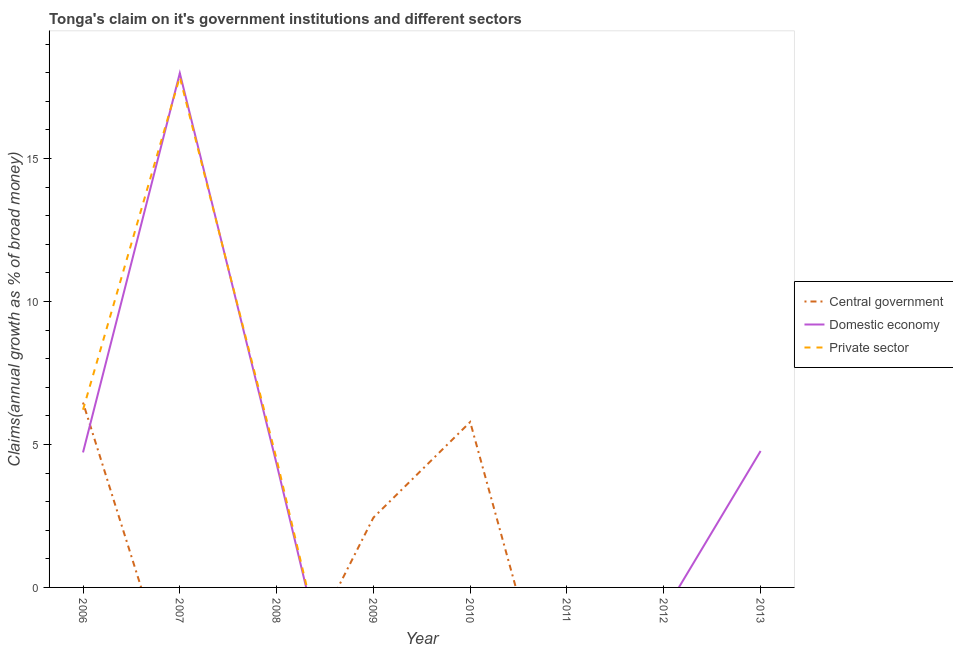How many different coloured lines are there?
Provide a succinct answer. 3. What is the percentage of claim on the central government in 2011?
Your answer should be compact. 0. Across all years, what is the maximum percentage of claim on the central government?
Keep it short and to the point. 6.47. Across all years, what is the minimum percentage of claim on the central government?
Your response must be concise. 0. What is the total percentage of claim on the central government in the graph?
Make the answer very short. 14.69. What is the difference between the percentage of claim on the domestic economy in 2012 and the percentage of claim on the central government in 2009?
Give a very brief answer. -2.44. What is the average percentage of claim on the private sector per year?
Your answer should be compact. 3.57. In the year 2006, what is the difference between the percentage of claim on the domestic economy and percentage of claim on the private sector?
Give a very brief answer. -1.49. What is the difference between the highest and the second highest percentage of claim on the domestic economy?
Your response must be concise. 13.21. What is the difference between the highest and the lowest percentage of claim on the domestic economy?
Your answer should be compact. 17.99. Is it the case that in every year, the sum of the percentage of claim on the central government and percentage of claim on the domestic economy is greater than the percentage of claim on the private sector?
Provide a succinct answer. No. What is the difference between two consecutive major ticks on the Y-axis?
Keep it short and to the point. 5. Does the graph contain any zero values?
Your response must be concise. Yes. How many legend labels are there?
Offer a very short reply. 3. What is the title of the graph?
Offer a very short reply. Tonga's claim on it's government institutions and different sectors. Does "Taxes" appear as one of the legend labels in the graph?
Your answer should be very brief. No. What is the label or title of the X-axis?
Your response must be concise. Year. What is the label or title of the Y-axis?
Keep it short and to the point. Claims(annual growth as % of broad money). What is the Claims(annual growth as % of broad money) of Central government in 2006?
Provide a succinct answer. 6.47. What is the Claims(annual growth as % of broad money) in Domestic economy in 2006?
Offer a terse response. 4.72. What is the Claims(annual growth as % of broad money) in Private sector in 2006?
Give a very brief answer. 6.22. What is the Claims(annual growth as % of broad money) of Domestic economy in 2007?
Your response must be concise. 17.99. What is the Claims(annual growth as % of broad money) of Private sector in 2007?
Provide a short and direct response. 17.85. What is the Claims(annual growth as % of broad money) in Central government in 2008?
Give a very brief answer. 0. What is the Claims(annual growth as % of broad money) of Domestic economy in 2008?
Provide a succinct answer. 4.32. What is the Claims(annual growth as % of broad money) in Private sector in 2008?
Provide a succinct answer. 4.48. What is the Claims(annual growth as % of broad money) in Central government in 2009?
Make the answer very short. 2.44. What is the Claims(annual growth as % of broad money) in Domestic economy in 2009?
Make the answer very short. 0. What is the Claims(annual growth as % of broad money) of Private sector in 2009?
Give a very brief answer. 0. What is the Claims(annual growth as % of broad money) of Central government in 2010?
Keep it short and to the point. 5.79. What is the Claims(annual growth as % of broad money) in Domestic economy in 2010?
Your answer should be compact. 0. What is the Claims(annual growth as % of broad money) in Private sector in 2011?
Your answer should be compact. 0. What is the Claims(annual growth as % of broad money) of Domestic economy in 2012?
Provide a short and direct response. 0. What is the Claims(annual growth as % of broad money) in Central government in 2013?
Your response must be concise. 0. What is the Claims(annual growth as % of broad money) of Domestic economy in 2013?
Your answer should be very brief. 4.77. Across all years, what is the maximum Claims(annual growth as % of broad money) in Central government?
Give a very brief answer. 6.47. Across all years, what is the maximum Claims(annual growth as % of broad money) in Domestic economy?
Offer a very short reply. 17.99. Across all years, what is the maximum Claims(annual growth as % of broad money) of Private sector?
Offer a terse response. 17.85. Across all years, what is the minimum Claims(annual growth as % of broad money) of Central government?
Offer a terse response. 0. What is the total Claims(annual growth as % of broad money) of Central government in the graph?
Provide a succinct answer. 14.69. What is the total Claims(annual growth as % of broad money) in Domestic economy in the graph?
Keep it short and to the point. 31.8. What is the total Claims(annual growth as % of broad money) of Private sector in the graph?
Give a very brief answer. 28.55. What is the difference between the Claims(annual growth as % of broad money) in Domestic economy in 2006 and that in 2007?
Give a very brief answer. -13.26. What is the difference between the Claims(annual growth as % of broad money) of Private sector in 2006 and that in 2007?
Offer a very short reply. -11.63. What is the difference between the Claims(annual growth as % of broad money) in Domestic economy in 2006 and that in 2008?
Offer a terse response. 0.4. What is the difference between the Claims(annual growth as % of broad money) of Private sector in 2006 and that in 2008?
Give a very brief answer. 1.73. What is the difference between the Claims(annual growth as % of broad money) of Central government in 2006 and that in 2009?
Your answer should be very brief. 4.02. What is the difference between the Claims(annual growth as % of broad money) in Central government in 2006 and that in 2010?
Your response must be concise. 0.68. What is the difference between the Claims(annual growth as % of broad money) of Domestic economy in 2006 and that in 2013?
Ensure brevity in your answer.  -0.05. What is the difference between the Claims(annual growth as % of broad money) in Domestic economy in 2007 and that in 2008?
Make the answer very short. 13.67. What is the difference between the Claims(annual growth as % of broad money) in Private sector in 2007 and that in 2008?
Provide a succinct answer. 13.37. What is the difference between the Claims(annual growth as % of broad money) of Domestic economy in 2007 and that in 2013?
Offer a very short reply. 13.21. What is the difference between the Claims(annual growth as % of broad money) in Domestic economy in 2008 and that in 2013?
Make the answer very short. -0.45. What is the difference between the Claims(annual growth as % of broad money) in Central government in 2009 and that in 2010?
Give a very brief answer. -3.34. What is the difference between the Claims(annual growth as % of broad money) of Central government in 2006 and the Claims(annual growth as % of broad money) of Domestic economy in 2007?
Offer a terse response. -11.52. What is the difference between the Claims(annual growth as % of broad money) in Central government in 2006 and the Claims(annual growth as % of broad money) in Private sector in 2007?
Ensure brevity in your answer.  -11.38. What is the difference between the Claims(annual growth as % of broad money) of Domestic economy in 2006 and the Claims(annual growth as % of broad money) of Private sector in 2007?
Give a very brief answer. -13.13. What is the difference between the Claims(annual growth as % of broad money) of Central government in 2006 and the Claims(annual growth as % of broad money) of Domestic economy in 2008?
Your answer should be compact. 2.15. What is the difference between the Claims(annual growth as % of broad money) of Central government in 2006 and the Claims(annual growth as % of broad money) of Private sector in 2008?
Offer a terse response. 1.98. What is the difference between the Claims(annual growth as % of broad money) in Domestic economy in 2006 and the Claims(annual growth as % of broad money) in Private sector in 2008?
Keep it short and to the point. 0.24. What is the difference between the Claims(annual growth as % of broad money) of Central government in 2006 and the Claims(annual growth as % of broad money) of Domestic economy in 2013?
Make the answer very short. 1.69. What is the difference between the Claims(annual growth as % of broad money) of Domestic economy in 2007 and the Claims(annual growth as % of broad money) of Private sector in 2008?
Provide a short and direct response. 13.51. What is the difference between the Claims(annual growth as % of broad money) of Central government in 2009 and the Claims(annual growth as % of broad money) of Domestic economy in 2013?
Offer a very short reply. -2.33. What is the difference between the Claims(annual growth as % of broad money) in Central government in 2010 and the Claims(annual growth as % of broad money) in Domestic economy in 2013?
Keep it short and to the point. 1.01. What is the average Claims(annual growth as % of broad money) in Central government per year?
Make the answer very short. 1.84. What is the average Claims(annual growth as % of broad money) in Domestic economy per year?
Your answer should be very brief. 3.97. What is the average Claims(annual growth as % of broad money) in Private sector per year?
Your response must be concise. 3.57. In the year 2006, what is the difference between the Claims(annual growth as % of broad money) in Central government and Claims(annual growth as % of broad money) in Domestic economy?
Your answer should be very brief. 1.74. In the year 2006, what is the difference between the Claims(annual growth as % of broad money) of Central government and Claims(annual growth as % of broad money) of Private sector?
Ensure brevity in your answer.  0.25. In the year 2006, what is the difference between the Claims(annual growth as % of broad money) in Domestic economy and Claims(annual growth as % of broad money) in Private sector?
Your answer should be very brief. -1.49. In the year 2007, what is the difference between the Claims(annual growth as % of broad money) in Domestic economy and Claims(annual growth as % of broad money) in Private sector?
Your response must be concise. 0.14. In the year 2008, what is the difference between the Claims(annual growth as % of broad money) in Domestic economy and Claims(annual growth as % of broad money) in Private sector?
Ensure brevity in your answer.  -0.16. What is the ratio of the Claims(annual growth as % of broad money) in Domestic economy in 2006 to that in 2007?
Your answer should be very brief. 0.26. What is the ratio of the Claims(annual growth as % of broad money) in Private sector in 2006 to that in 2007?
Your response must be concise. 0.35. What is the ratio of the Claims(annual growth as % of broad money) in Domestic economy in 2006 to that in 2008?
Give a very brief answer. 1.09. What is the ratio of the Claims(annual growth as % of broad money) in Private sector in 2006 to that in 2008?
Your response must be concise. 1.39. What is the ratio of the Claims(annual growth as % of broad money) in Central government in 2006 to that in 2009?
Provide a succinct answer. 2.65. What is the ratio of the Claims(annual growth as % of broad money) in Central government in 2006 to that in 2010?
Provide a succinct answer. 1.12. What is the ratio of the Claims(annual growth as % of broad money) of Domestic economy in 2007 to that in 2008?
Provide a succinct answer. 4.16. What is the ratio of the Claims(annual growth as % of broad money) of Private sector in 2007 to that in 2008?
Your answer should be very brief. 3.98. What is the ratio of the Claims(annual growth as % of broad money) in Domestic economy in 2007 to that in 2013?
Provide a short and direct response. 3.77. What is the ratio of the Claims(annual growth as % of broad money) of Domestic economy in 2008 to that in 2013?
Your response must be concise. 0.91. What is the ratio of the Claims(annual growth as % of broad money) of Central government in 2009 to that in 2010?
Provide a succinct answer. 0.42. What is the difference between the highest and the second highest Claims(annual growth as % of broad money) of Central government?
Make the answer very short. 0.68. What is the difference between the highest and the second highest Claims(annual growth as % of broad money) in Domestic economy?
Offer a terse response. 13.21. What is the difference between the highest and the second highest Claims(annual growth as % of broad money) in Private sector?
Keep it short and to the point. 11.63. What is the difference between the highest and the lowest Claims(annual growth as % of broad money) of Central government?
Make the answer very short. 6.47. What is the difference between the highest and the lowest Claims(annual growth as % of broad money) in Domestic economy?
Give a very brief answer. 17.99. What is the difference between the highest and the lowest Claims(annual growth as % of broad money) in Private sector?
Offer a terse response. 17.85. 